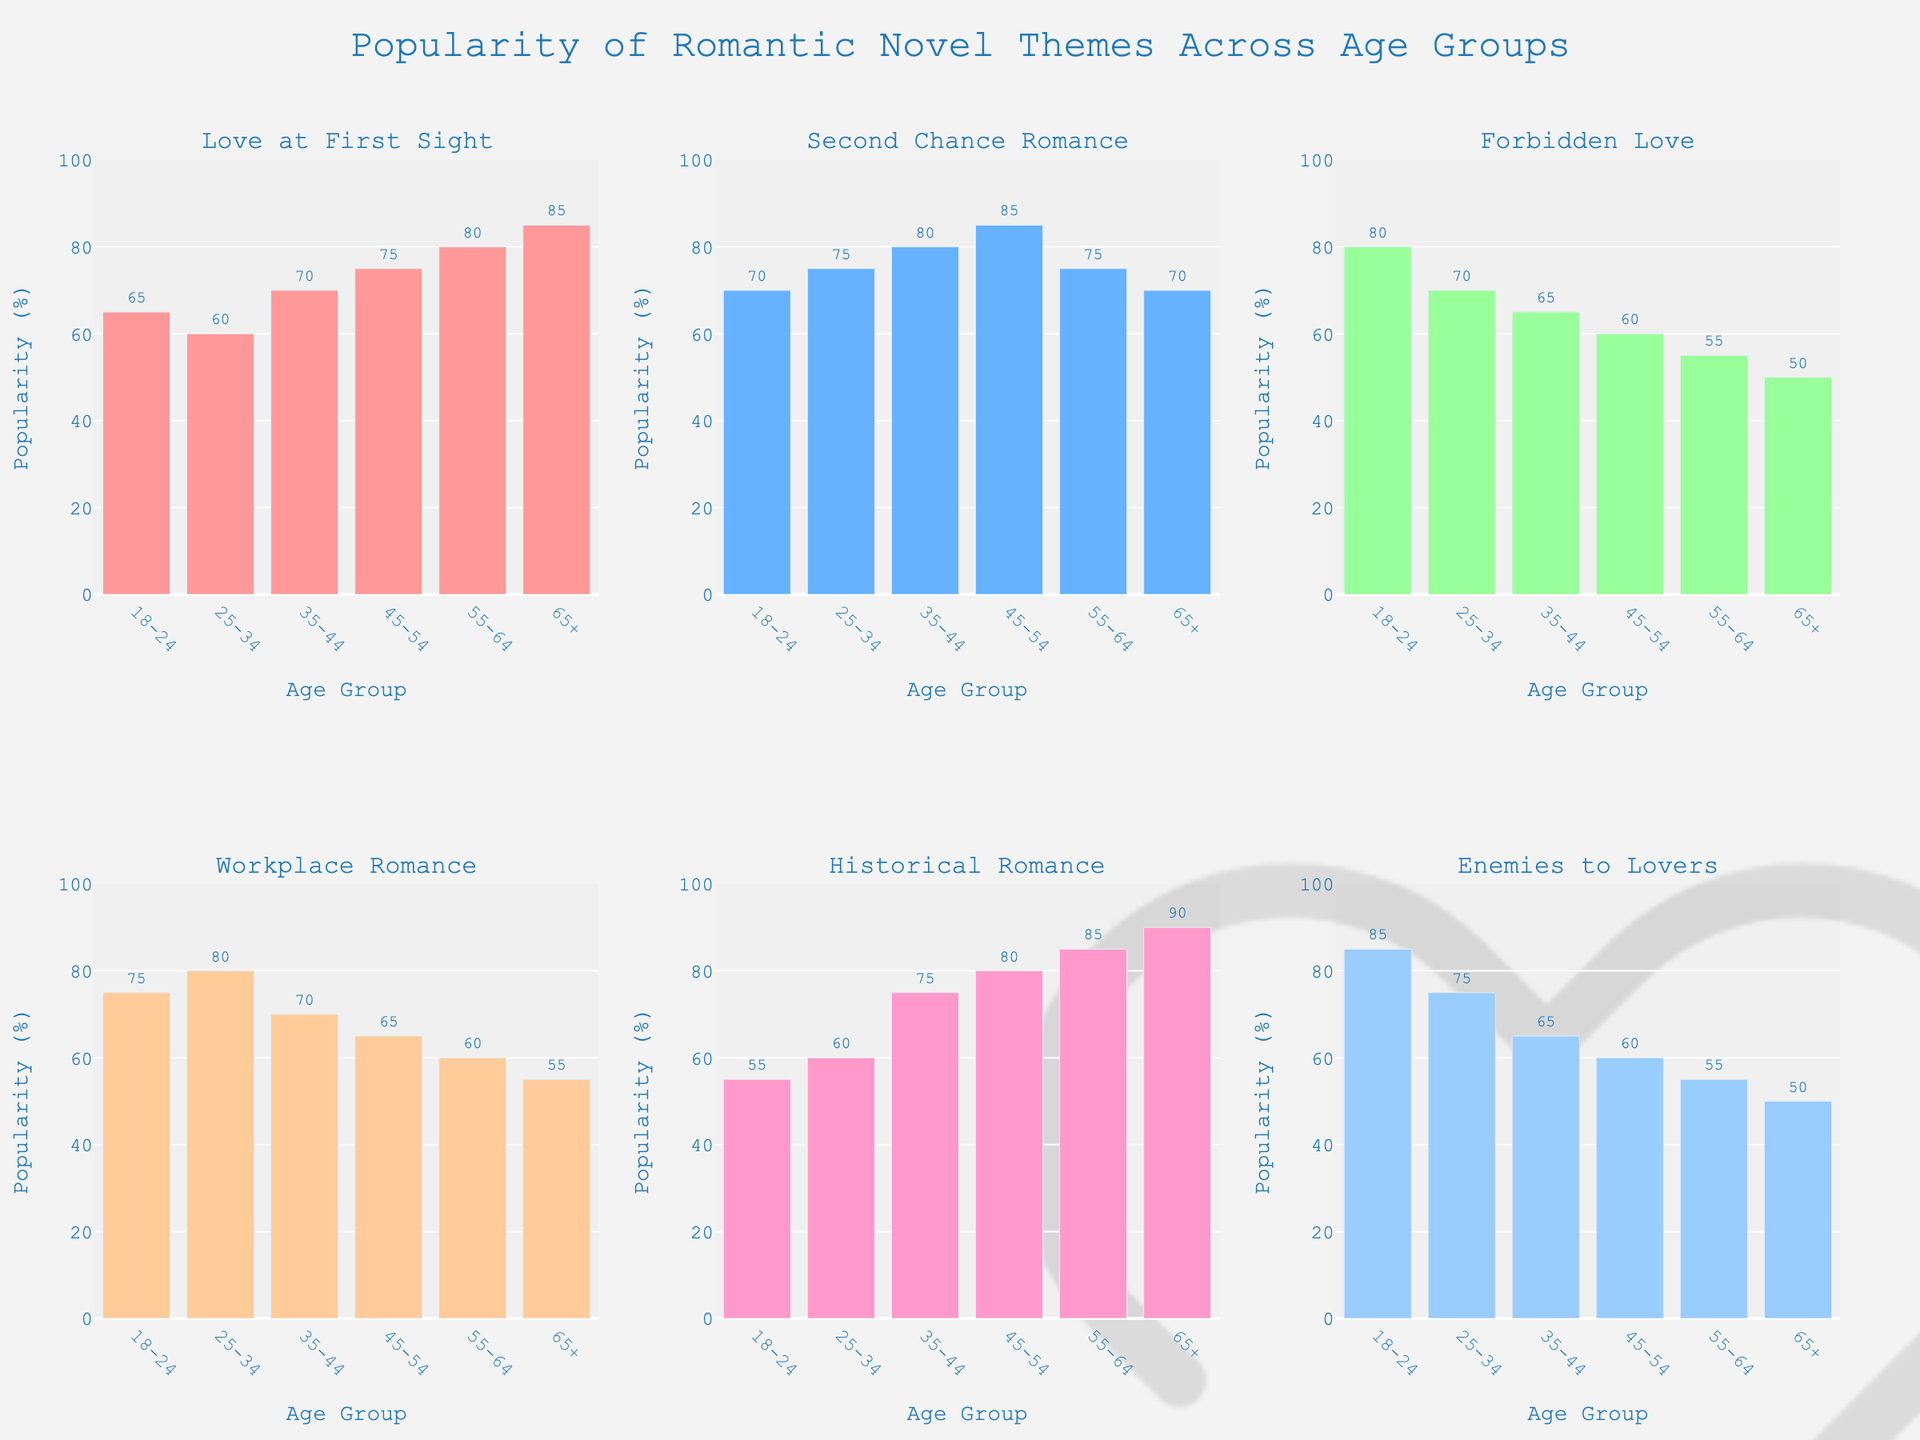What's the most popular romantic novel theme for the 18-24 age group? The highest bar for the 18-24 age group belongs to "Enemies to Lovers," which has a popularity percentage of 85%.
Answer: Enemies to Lovers Between the 35-44 and 45-54 age groups, which one has a higher preference for "Second Chance Romance"? Comparing the bars for "Second Chance Romance," the 35-44 group has a value of 80%, while the 45-54 group has a value of 85%.
Answer: 45-54 What's the average popularity of "Historical Romance" for all age groups? Summing the values for "Historical Romance" across all age groups and then dividing by the number of age groups: (55 + 60 + 75 + 80 + 85 + 90) / 6 = 74.17%
Answer: 74.17% Which theme shows a decreasing trend in popularity as the age group increases? Observing the bars, "Forbidden Love" decreases as the age increases from 80 to 50%.
Answer: Forbidden Love Among the themes "Love at First Sight" and "Workplace Romance," which age group shows the largest difference in their popularity? Subtracting the popularity values for "Love at First Sight" and "Workplace Romance" across age groups, the largest difference is for the 25-34 group: 60% - 80% = -20%.
Answer: 25-34 How many themes are most popular with the 55-64 age group compared to other age groups? The 55-64 age group has the highest popularity in "Love at First Sight" (80%), "Historical Romance" (85%), and "Second Chance Romance" compared to other age groups where they share the same value with the 35-44 age group.
Answer: 2 What is the second most popular theme for the 45-54 age group? The bar for "Love at First Sight" is the second highest for the 45-54 age group, with a popularity of 75%.
Answer: Love at First Sight Which age group has the least interest in "Enemies to Lovers"? The age group with the shortest bar for "Enemies to Lovers" is the 65+, with a value of 50%.
Answer: 65+ What is the combined popularity of "Workplace Romance" for the 18-24 and 25-34 age groups? Adding the values: 75% (18-24) + 80% (25-34) = 155%.
Answer: 155% 